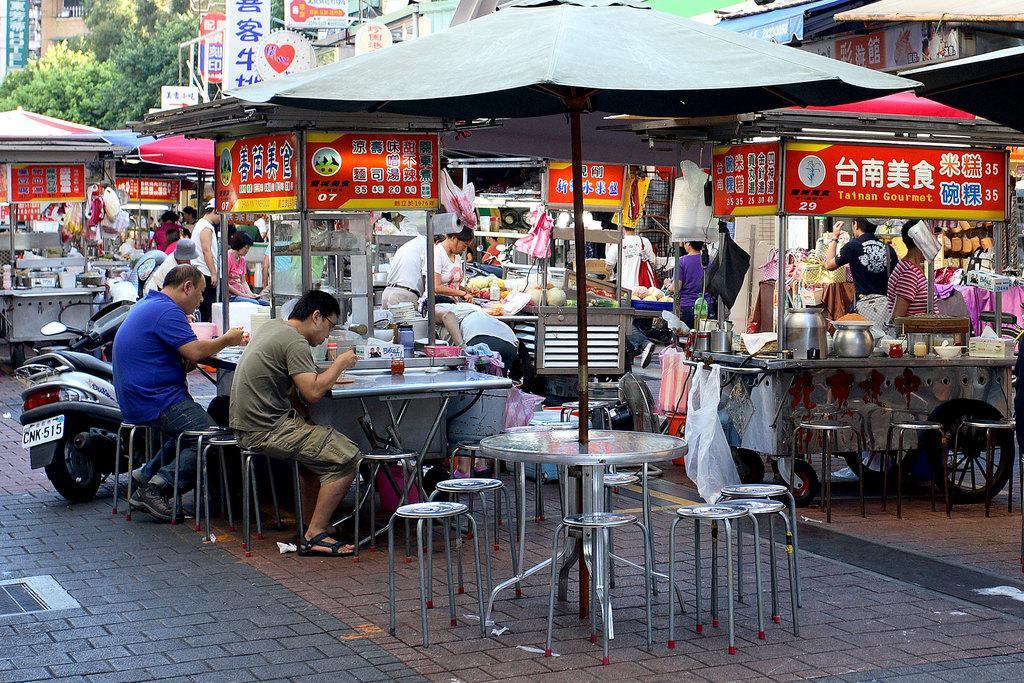Could you give a brief overview of what you see in this image? There are tables and stools. On the stools two persons are sitting. Also there is a tent. On the left side there is a scooter with a number plates. There are many food stalls. Also there are many people. Inside the food stalls there are vessels, food items and many other things. In the background there are trees and banners. 